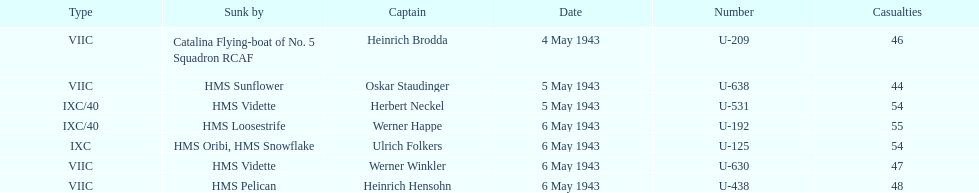Which u-boat was the first to sink U-209. Would you be able to parse every entry in this table? {'header': ['Type', 'Sunk by', 'Captain', 'Date', 'Number', 'Casualties'], 'rows': [['VIIC', 'Catalina Flying-boat of No. 5 Squadron RCAF', 'Heinrich Brodda', '4 May 1943', 'U-209', '46'], ['VIIC', 'HMS Sunflower', 'Oskar Staudinger', '5 May 1943', 'U-638', '44'], ['IXC/40', 'HMS Vidette', 'Herbert Neckel', '5 May 1943', 'U-531', '54'], ['IXC/40', 'HMS Loosestrife', 'Werner Happe', '6 May 1943', 'U-192', '55'], ['IXC', 'HMS Oribi, HMS Snowflake', 'Ulrich Folkers', '6 May 1943', 'U-125', '54'], ['VIIC', 'HMS Vidette', 'Werner Winkler', '6 May 1943', 'U-630', '47'], ['VIIC', 'HMS Pelican', 'Heinrich Hensohn', '6 May 1943', 'U-438', '48']]} 